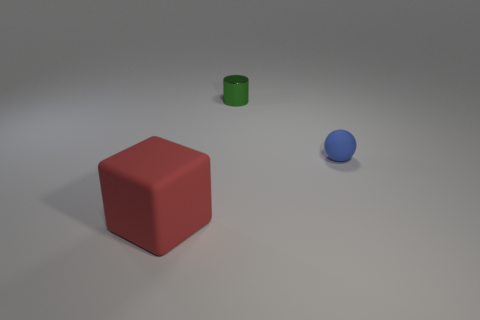Subtract all big blocks. Subtract all big red things. How many objects are left? 1 Add 2 tiny green cylinders. How many tiny green cylinders are left? 3 Add 2 tiny green metal spheres. How many tiny green metal spheres exist? 2 Add 2 gray objects. How many objects exist? 5 Subtract 0 red balls. How many objects are left? 3 Subtract all cylinders. How many objects are left? 2 Subtract 1 blocks. How many blocks are left? 0 Subtract all yellow cylinders. Subtract all purple blocks. How many cylinders are left? 1 Subtract all yellow spheres. How many yellow cylinders are left? 0 